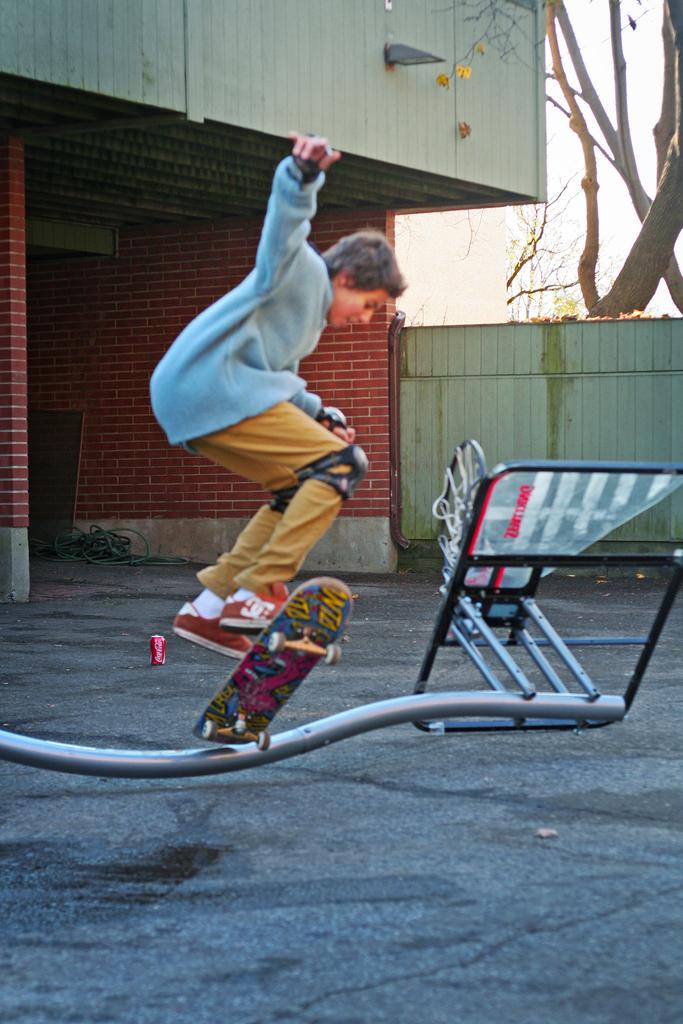Who is the main subject in the image? There is a boy in the image. What is the boy doing in the image? The boy is jumping with a skateboard. Can you describe the item on the path? Unfortunately, the facts provided do not give any information about the item on the path. What is visible behind the boy? There is a wall and a tree behind the boy. What can be seen in the background of the image? The sky is visible in the background. What type of acoustics can be heard in the image? There is no information about any sounds or acoustics in the image. Can you describe the conversation between the boy and the plant in the image? There is no plant present in the image, and the boy is not engaged in any conversation. 